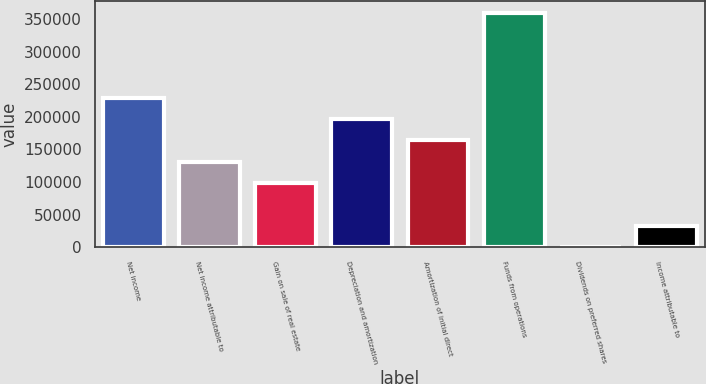Convert chart. <chart><loc_0><loc_0><loc_500><loc_500><bar_chart><fcel>Net income<fcel>Net income attributable to<fcel>Gain on sale of real estate<fcel>Depreciation and amortization<fcel>Amortization of initial direct<fcel>Funds from operations<fcel>Dividends on preferred shares<fcel>Income attributable to<nl><fcel>229480<fcel>131363<fcel>98657.8<fcel>196775<fcel>164069<fcel>359291<fcel>541<fcel>33246.6<nl></chart> 